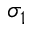<formula> <loc_0><loc_0><loc_500><loc_500>\sigma _ { 1 }</formula> 